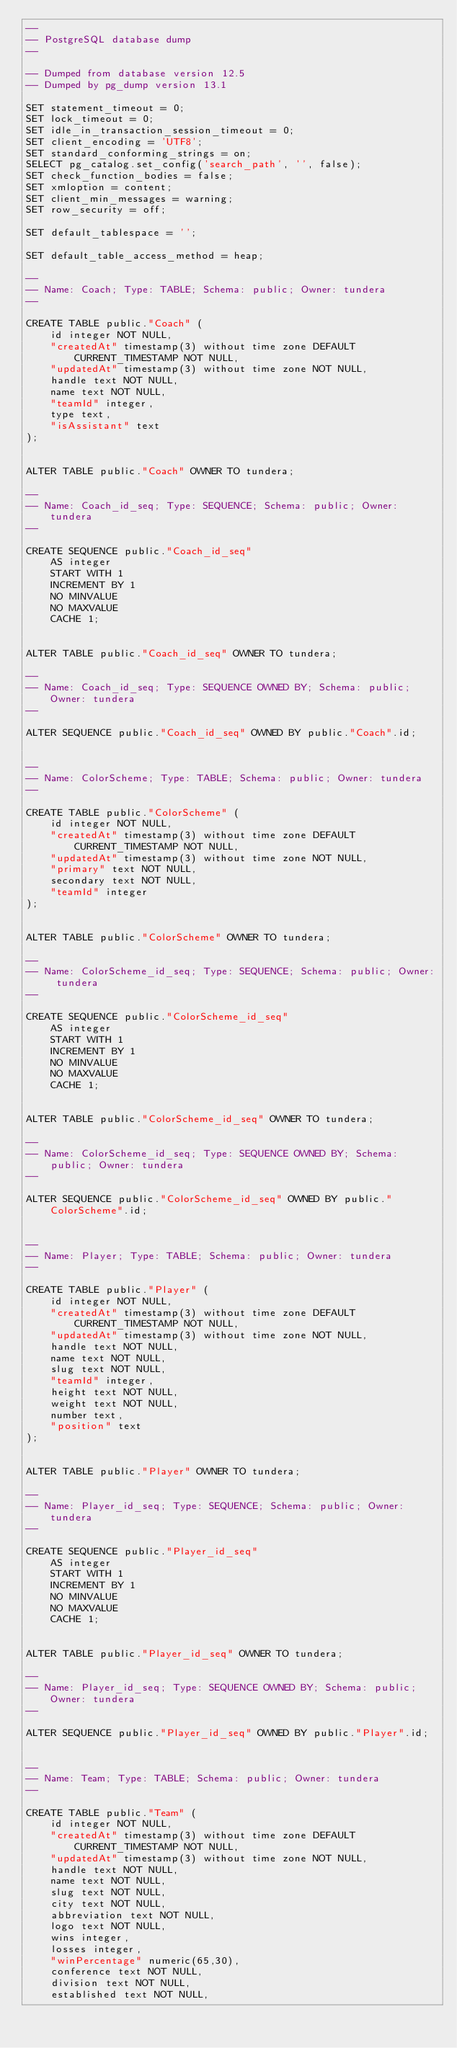<code> <loc_0><loc_0><loc_500><loc_500><_SQL_>--
-- PostgreSQL database dump
--

-- Dumped from database version 12.5
-- Dumped by pg_dump version 13.1

SET statement_timeout = 0;
SET lock_timeout = 0;
SET idle_in_transaction_session_timeout = 0;
SET client_encoding = 'UTF8';
SET standard_conforming_strings = on;
SELECT pg_catalog.set_config('search_path', '', false);
SET check_function_bodies = false;
SET xmloption = content;
SET client_min_messages = warning;
SET row_security = off;

SET default_tablespace = '';

SET default_table_access_method = heap;

--
-- Name: Coach; Type: TABLE; Schema: public; Owner: tundera
--

CREATE TABLE public."Coach" (
    id integer NOT NULL,
    "createdAt" timestamp(3) without time zone DEFAULT CURRENT_TIMESTAMP NOT NULL,
    "updatedAt" timestamp(3) without time zone NOT NULL,
    handle text NOT NULL,
    name text NOT NULL,
    "teamId" integer,
    type text,
    "isAssistant" text
);


ALTER TABLE public."Coach" OWNER TO tundera;

--
-- Name: Coach_id_seq; Type: SEQUENCE; Schema: public; Owner: tundera
--

CREATE SEQUENCE public."Coach_id_seq"
    AS integer
    START WITH 1
    INCREMENT BY 1
    NO MINVALUE
    NO MAXVALUE
    CACHE 1;


ALTER TABLE public."Coach_id_seq" OWNER TO tundera;

--
-- Name: Coach_id_seq; Type: SEQUENCE OWNED BY; Schema: public; Owner: tundera
--

ALTER SEQUENCE public."Coach_id_seq" OWNED BY public."Coach".id;


--
-- Name: ColorScheme; Type: TABLE; Schema: public; Owner: tundera
--

CREATE TABLE public."ColorScheme" (
    id integer NOT NULL,
    "createdAt" timestamp(3) without time zone DEFAULT CURRENT_TIMESTAMP NOT NULL,
    "updatedAt" timestamp(3) without time zone NOT NULL,
    "primary" text NOT NULL,
    secondary text NOT NULL,
    "teamId" integer
);


ALTER TABLE public."ColorScheme" OWNER TO tundera;

--
-- Name: ColorScheme_id_seq; Type: SEQUENCE; Schema: public; Owner: tundera
--

CREATE SEQUENCE public."ColorScheme_id_seq"
    AS integer
    START WITH 1
    INCREMENT BY 1
    NO MINVALUE
    NO MAXVALUE
    CACHE 1;


ALTER TABLE public."ColorScheme_id_seq" OWNER TO tundera;

--
-- Name: ColorScheme_id_seq; Type: SEQUENCE OWNED BY; Schema: public; Owner: tundera
--

ALTER SEQUENCE public."ColorScheme_id_seq" OWNED BY public."ColorScheme".id;


--
-- Name: Player; Type: TABLE; Schema: public; Owner: tundera
--

CREATE TABLE public."Player" (
    id integer NOT NULL,
    "createdAt" timestamp(3) without time zone DEFAULT CURRENT_TIMESTAMP NOT NULL,
    "updatedAt" timestamp(3) without time zone NOT NULL,
    handle text NOT NULL,
    name text NOT NULL,
    slug text NOT NULL,
    "teamId" integer,
    height text NOT NULL,
    weight text NOT NULL,
    number text,
    "position" text
);


ALTER TABLE public."Player" OWNER TO tundera;

--
-- Name: Player_id_seq; Type: SEQUENCE; Schema: public; Owner: tundera
--

CREATE SEQUENCE public."Player_id_seq"
    AS integer
    START WITH 1
    INCREMENT BY 1
    NO MINVALUE
    NO MAXVALUE
    CACHE 1;


ALTER TABLE public."Player_id_seq" OWNER TO tundera;

--
-- Name: Player_id_seq; Type: SEQUENCE OWNED BY; Schema: public; Owner: tundera
--

ALTER SEQUENCE public."Player_id_seq" OWNED BY public."Player".id;


--
-- Name: Team; Type: TABLE; Schema: public; Owner: tundera
--

CREATE TABLE public."Team" (
    id integer NOT NULL,
    "createdAt" timestamp(3) without time zone DEFAULT CURRENT_TIMESTAMP NOT NULL,
    "updatedAt" timestamp(3) without time zone NOT NULL,
    handle text NOT NULL,
    name text NOT NULL,
    slug text NOT NULL,
    city text NOT NULL,
    abbreviation text NOT NULL,
    logo text NOT NULL,
    wins integer,
    losses integer,
    "winPercentage" numeric(65,30),
    conference text NOT NULL,
    division text NOT NULL,
    established text NOT NULL,</code> 